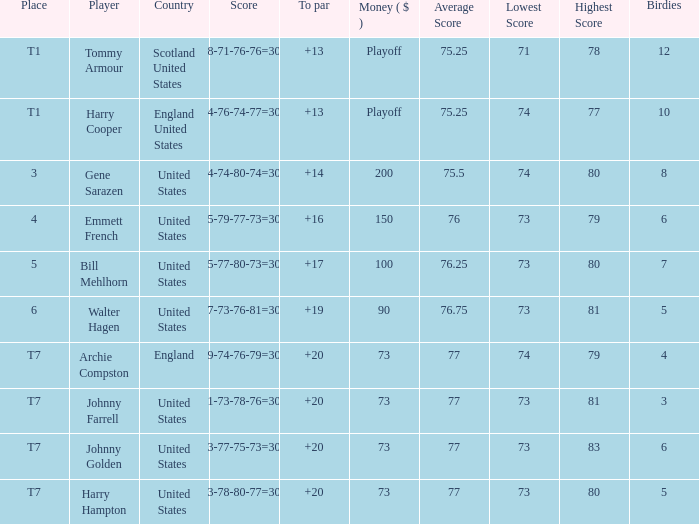What is the ranking when Archie Compston is the player and the money is $73? T7. Would you mind parsing the complete table? {'header': ['Place', 'Player', 'Country', 'Score', 'To par', 'Money ( $ )', 'Average Score', 'Lowest Score', 'Highest Score', 'Birdies'], 'rows': [['T1', 'Tommy Armour', 'Scotland United States', '78-71-76-76=301', '+13', 'Playoff', '75.25', '71', '78', '12'], ['T1', 'Harry Cooper', 'England United States', '74-76-74-77=301', '+13', 'Playoff', '75.25', '74', '77', '10'], ['3', 'Gene Sarazen', 'United States', '74-74-80-74=302', '+14', '200', '75.5', '74', '80', '8'], ['4', 'Emmett French', 'United States', '75-79-77-73=304', '+16', '150', '76', '73', '79', '6'], ['5', 'Bill Mehlhorn', 'United States', '75-77-80-73=305', '+17', '100', '76.25', '73', '80', '7'], ['6', 'Walter Hagen', 'United States', '77-73-76-81=307', '+19', '90', '76.75', '73', '81', '5'], ['T7', 'Archie Compston', 'England', '79-74-76-79=308', '+20', '73', '77', '74', '79', '4'], ['T7', 'Johnny Farrell', 'United States', '81-73-78-76=308', '+20', '73', '77', '73', '81', '3'], ['T7', 'Johnny Golden', 'United States', '83-77-75-73=308', '+20', '73', '77', '73', '83', '6'], ['T7', 'Harry Hampton', 'United States', '73-78-80-77=308', '+20', '73', '77', '73', '80', '5']]} 